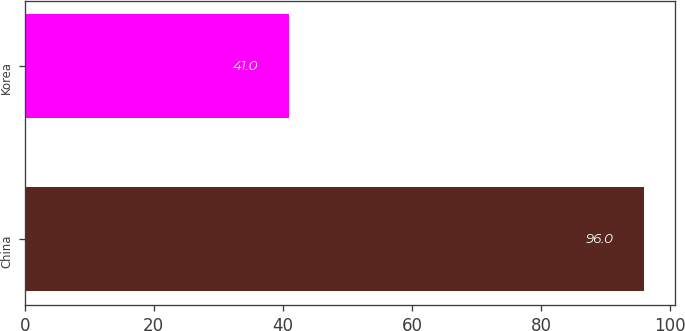<chart> <loc_0><loc_0><loc_500><loc_500><bar_chart><fcel>China<fcel>Korea<nl><fcel>96<fcel>41<nl></chart> 